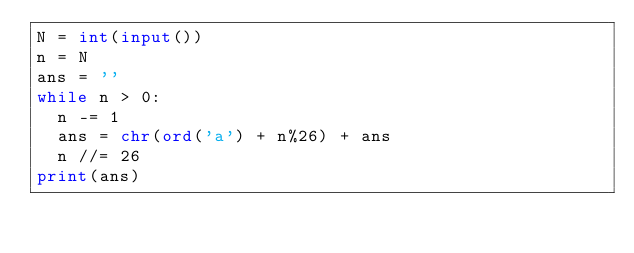Convert code to text. <code><loc_0><loc_0><loc_500><loc_500><_Python_>N = int(input())
n = N
ans = ''
while n > 0:
  n -= 1
  ans = chr(ord('a') + n%26) + ans
  n //= 26
print(ans)</code> 